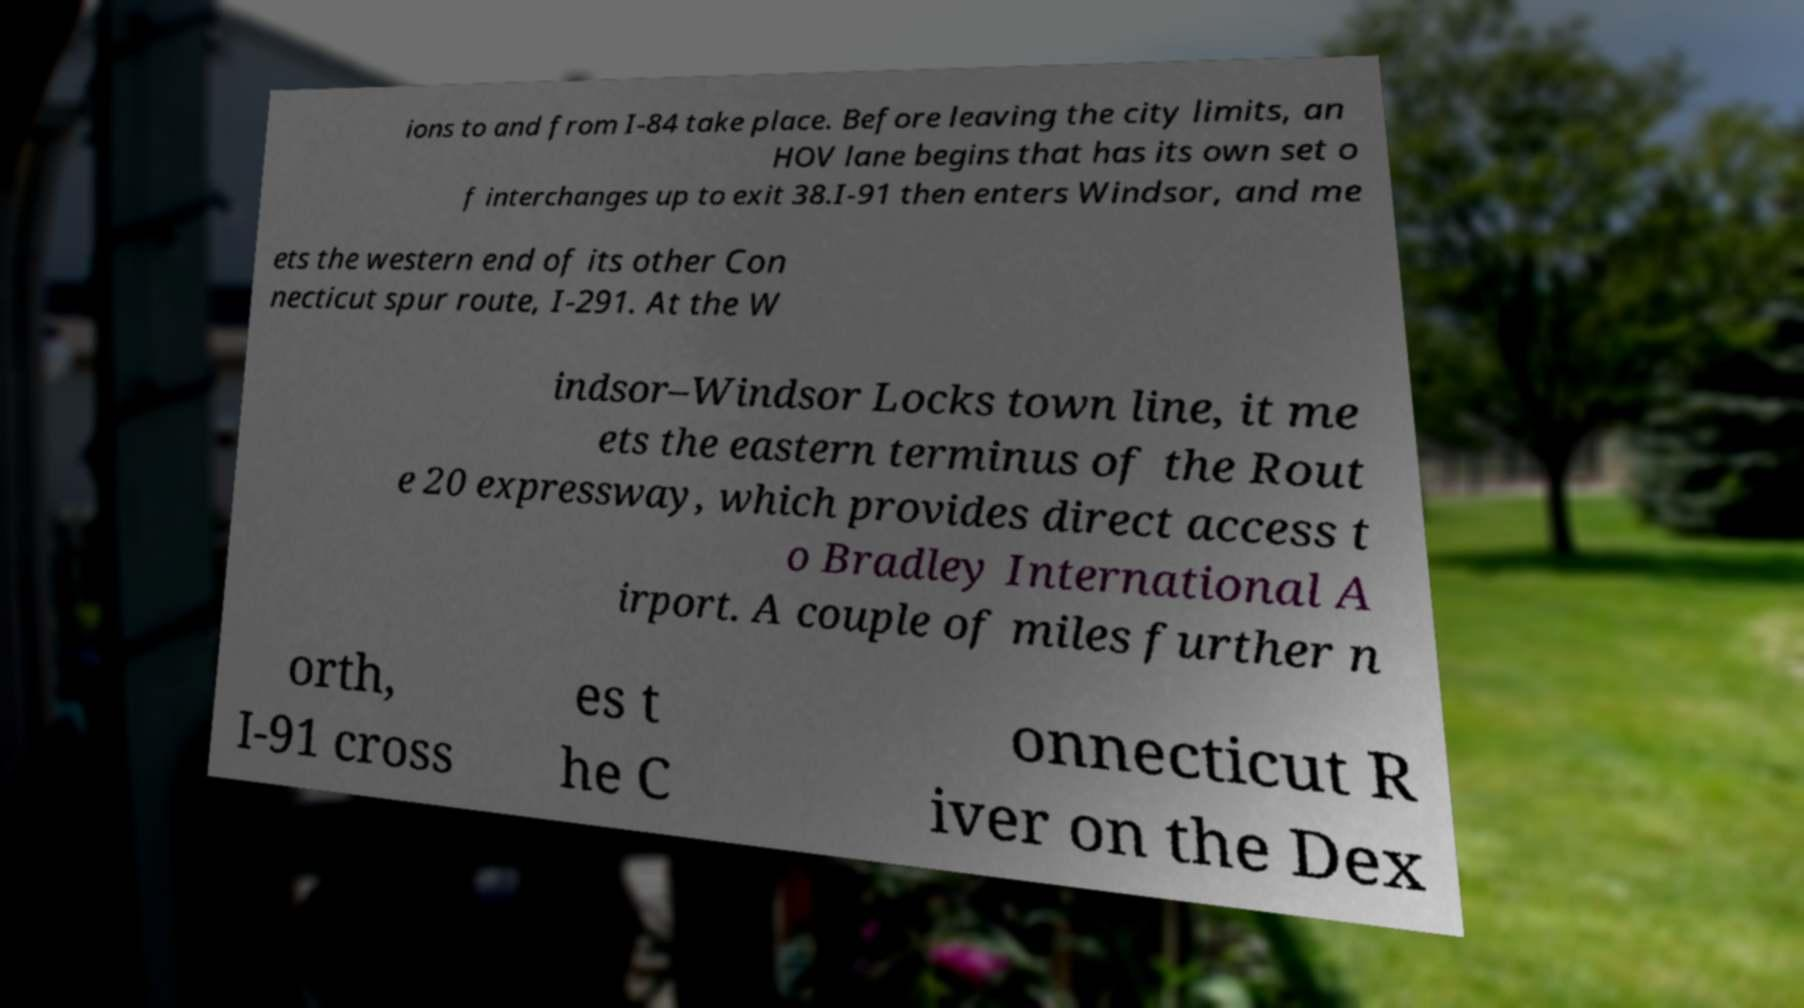Could you extract and type out the text from this image? ions to and from I-84 take place. Before leaving the city limits, an HOV lane begins that has its own set o f interchanges up to exit 38.I-91 then enters Windsor, and me ets the western end of its other Con necticut spur route, I-291. At the W indsor–Windsor Locks town line, it me ets the eastern terminus of the Rout e 20 expressway, which provides direct access t o Bradley International A irport. A couple of miles further n orth, I-91 cross es t he C onnecticut R iver on the Dex 